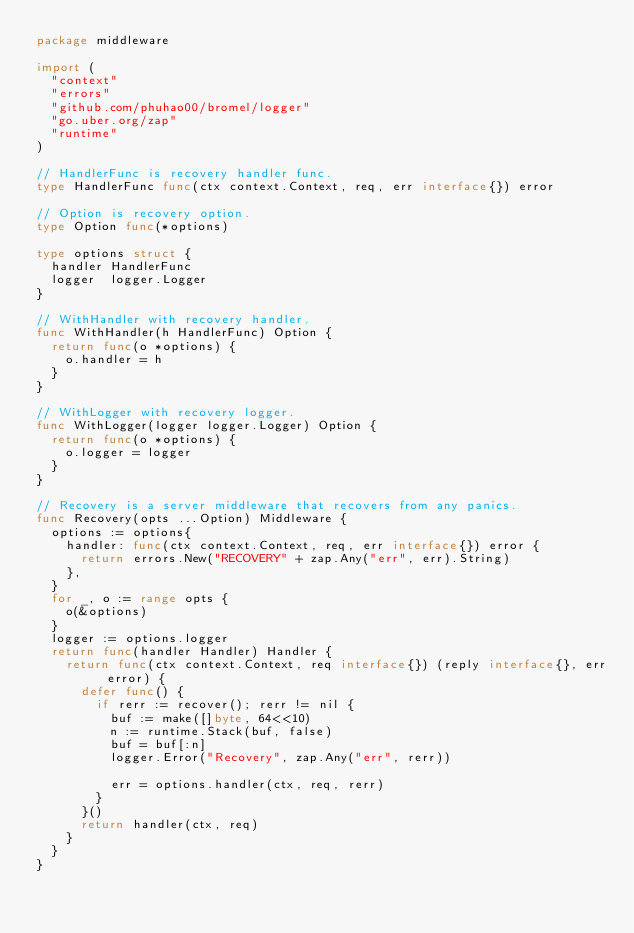Convert code to text. <code><loc_0><loc_0><loc_500><loc_500><_Go_>package middleware

import (
	"context"
	"errors"
	"github.com/phuhao00/bromel/logger"
	"go.uber.org/zap"
	"runtime"
)

// HandlerFunc is recovery handler func.
type HandlerFunc func(ctx context.Context, req, err interface{}) error

// Option is recovery option.
type Option func(*options)

type options struct {
	handler HandlerFunc
	logger  logger.Logger
}

// WithHandler with recovery handler.
func WithHandler(h HandlerFunc) Option {
	return func(o *options) {
		o.handler = h
	}
}

// WithLogger with recovery logger.
func WithLogger(logger logger.Logger) Option {
	return func(o *options) {
		o.logger = logger
	}
}

// Recovery is a server middleware that recovers from any panics.
func Recovery(opts ...Option) Middleware {
	options := options{
		handler: func(ctx context.Context, req, err interface{}) error {
			return errors.New("RECOVERY" + zap.Any("err", err).String)
		},
	}
	for _, o := range opts {
		o(&options)
	}
	logger := options.logger
	return func(handler Handler) Handler {
		return func(ctx context.Context, req interface{}) (reply interface{}, err error) {
			defer func() {
				if rerr := recover(); rerr != nil {
					buf := make([]byte, 64<<10)
					n := runtime.Stack(buf, false)
					buf = buf[:n]
					logger.Error("Recovery", zap.Any("err", rerr))

					err = options.handler(ctx, req, rerr)
				}
			}()
			return handler(ctx, req)
		}
	}
}
</code> 